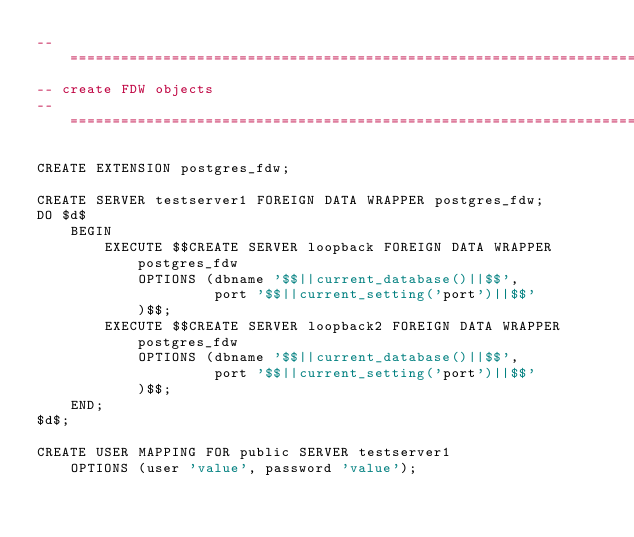<code> <loc_0><loc_0><loc_500><loc_500><_SQL_>-- ===================================================================
-- create FDW objects
-- ===================================================================

CREATE EXTENSION postgres_fdw;

CREATE SERVER testserver1 FOREIGN DATA WRAPPER postgres_fdw;
DO $d$
    BEGIN
        EXECUTE $$CREATE SERVER loopback FOREIGN DATA WRAPPER postgres_fdw
            OPTIONS (dbname '$$||current_database()||$$',
                     port '$$||current_setting('port')||$$'
            )$$;
        EXECUTE $$CREATE SERVER loopback2 FOREIGN DATA WRAPPER postgres_fdw
            OPTIONS (dbname '$$||current_database()||$$',
                     port '$$||current_setting('port')||$$'
            )$$;
    END;
$d$;

CREATE USER MAPPING FOR public SERVER testserver1
	OPTIONS (user 'value', password 'value');</code> 